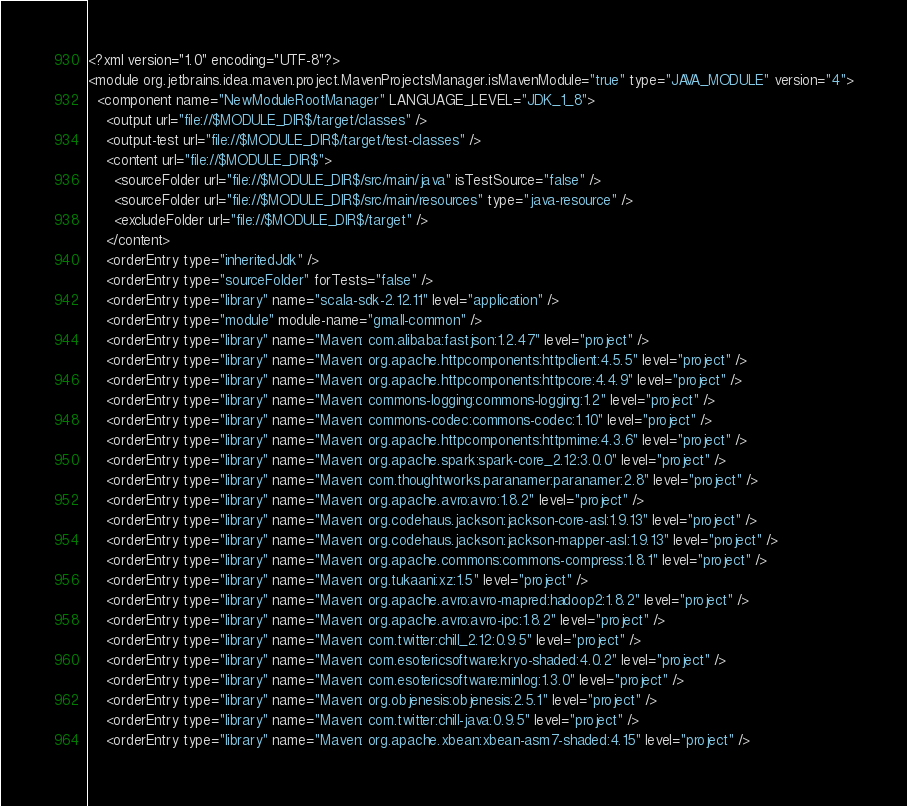Convert code to text. <code><loc_0><loc_0><loc_500><loc_500><_XML_><?xml version="1.0" encoding="UTF-8"?>
<module org.jetbrains.idea.maven.project.MavenProjectsManager.isMavenModule="true" type="JAVA_MODULE" version="4">
  <component name="NewModuleRootManager" LANGUAGE_LEVEL="JDK_1_8">
    <output url="file://$MODULE_DIR$/target/classes" />
    <output-test url="file://$MODULE_DIR$/target/test-classes" />
    <content url="file://$MODULE_DIR$">
      <sourceFolder url="file://$MODULE_DIR$/src/main/java" isTestSource="false" />
      <sourceFolder url="file://$MODULE_DIR$/src/main/resources" type="java-resource" />
      <excludeFolder url="file://$MODULE_DIR$/target" />
    </content>
    <orderEntry type="inheritedJdk" />
    <orderEntry type="sourceFolder" forTests="false" />
    <orderEntry type="library" name="scala-sdk-2.12.11" level="application" />
    <orderEntry type="module" module-name="gmall-common" />
    <orderEntry type="library" name="Maven: com.alibaba:fastjson:1.2.47" level="project" />
    <orderEntry type="library" name="Maven: org.apache.httpcomponents:httpclient:4.5.5" level="project" />
    <orderEntry type="library" name="Maven: org.apache.httpcomponents:httpcore:4.4.9" level="project" />
    <orderEntry type="library" name="Maven: commons-logging:commons-logging:1.2" level="project" />
    <orderEntry type="library" name="Maven: commons-codec:commons-codec:1.10" level="project" />
    <orderEntry type="library" name="Maven: org.apache.httpcomponents:httpmime:4.3.6" level="project" />
    <orderEntry type="library" name="Maven: org.apache.spark:spark-core_2.12:3.0.0" level="project" />
    <orderEntry type="library" name="Maven: com.thoughtworks.paranamer:paranamer:2.8" level="project" />
    <orderEntry type="library" name="Maven: org.apache.avro:avro:1.8.2" level="project" />
    <orderEntry type="library" name="Maven: org.codehaus.jackson:jackson-core-asl:1.9.13" level="project" />
    <orderEntry type="library" name="Maven: org.codehaus.jackson:jackson-mapper-asl:1.9.13" level="project" />
    <orderEntry type="library" name="Maven: org.apache.commons:commons-compress:1.8.1" level="project" />
    <orderEntry type="library" name="Maven: org.tukaani:xz:1.5" level="project" />
    <orderEntry type="library" name="Maven: org.apache.avro:avro-mapred:hadoop2:1.8.2" level="project" />
    <orderEntry type="library" name="Maven: org.apache.avro:avro-ipc:1.8.2" level="project" />
    <orderEntry type="library" name="Maven: com.twitter:chill_2.12:0.9.5" level="project" />
    <orderEntry type="library" name="Maven: com.esotericsoftware:kryo-shaded:4.0.2" level="project" />
    <orderEntry type="library" name="Maven: com.esotericsoftware:minlog:1.3.0" level="project" />
    <orderEntry type="library" name="Maven: org.objenesis:objenesis:2.5.1" level="project" />
    <orderEntry type="library" name="Maven: com.twitter:chill-java:0.9.5" level="project" />
    <orderEntry type="library" name="Maven: org.apache.xbean:xbean-asm7-shaded:4.15" level="project" /></code> 